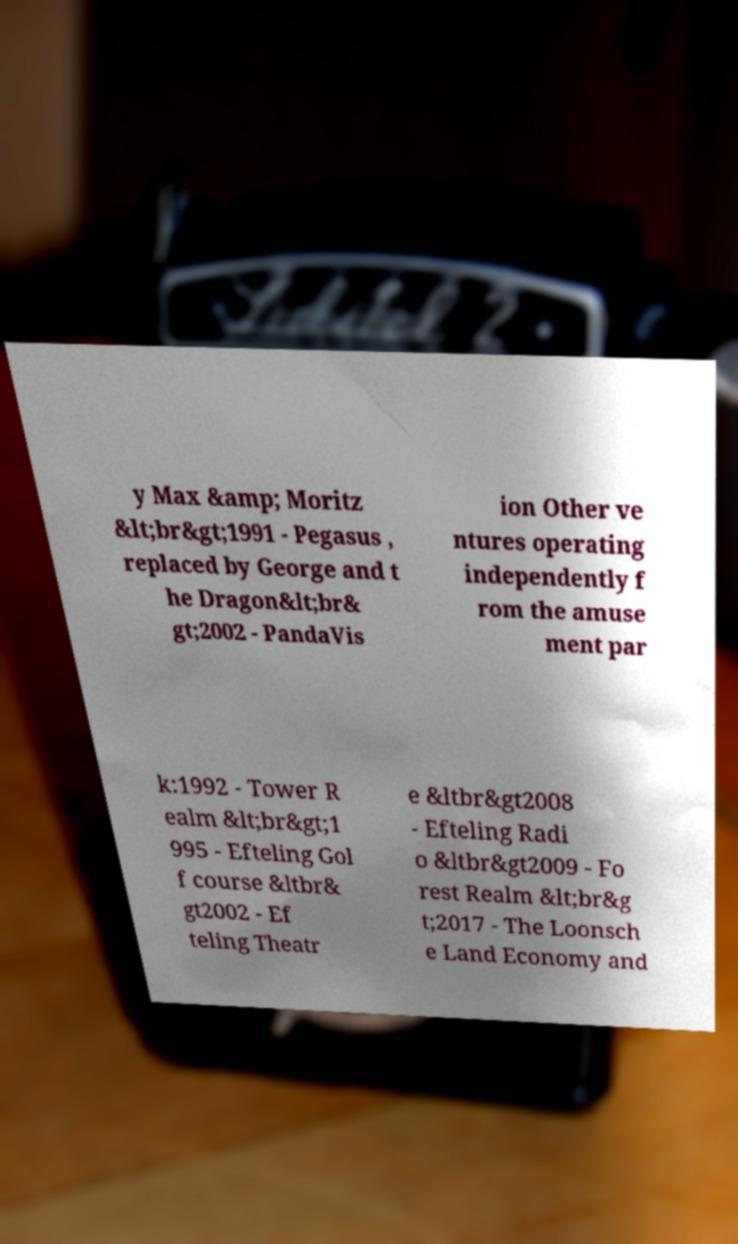Can you accurately transcribe the text from the provided image for me? y Max &amp; Moritz &lt;br&gt;1991 - Pegasus , replaced by George and t he Dragon&lt;br& gt;2002 - PandaVis ion Other ve ntures operating independently f rom the amuse ment par k:1992 - Tower R ealm &lt;br&gt;1 995 - Efteling Gol f course &ltbr& gt2002 - Ef teling Theatr e &ltbr&gt2008 - Efteling Radi o &ltbr&gt2009 - Fo rest Realm &lt;br&g t;2017 - The Loonsch e Land Economy and 